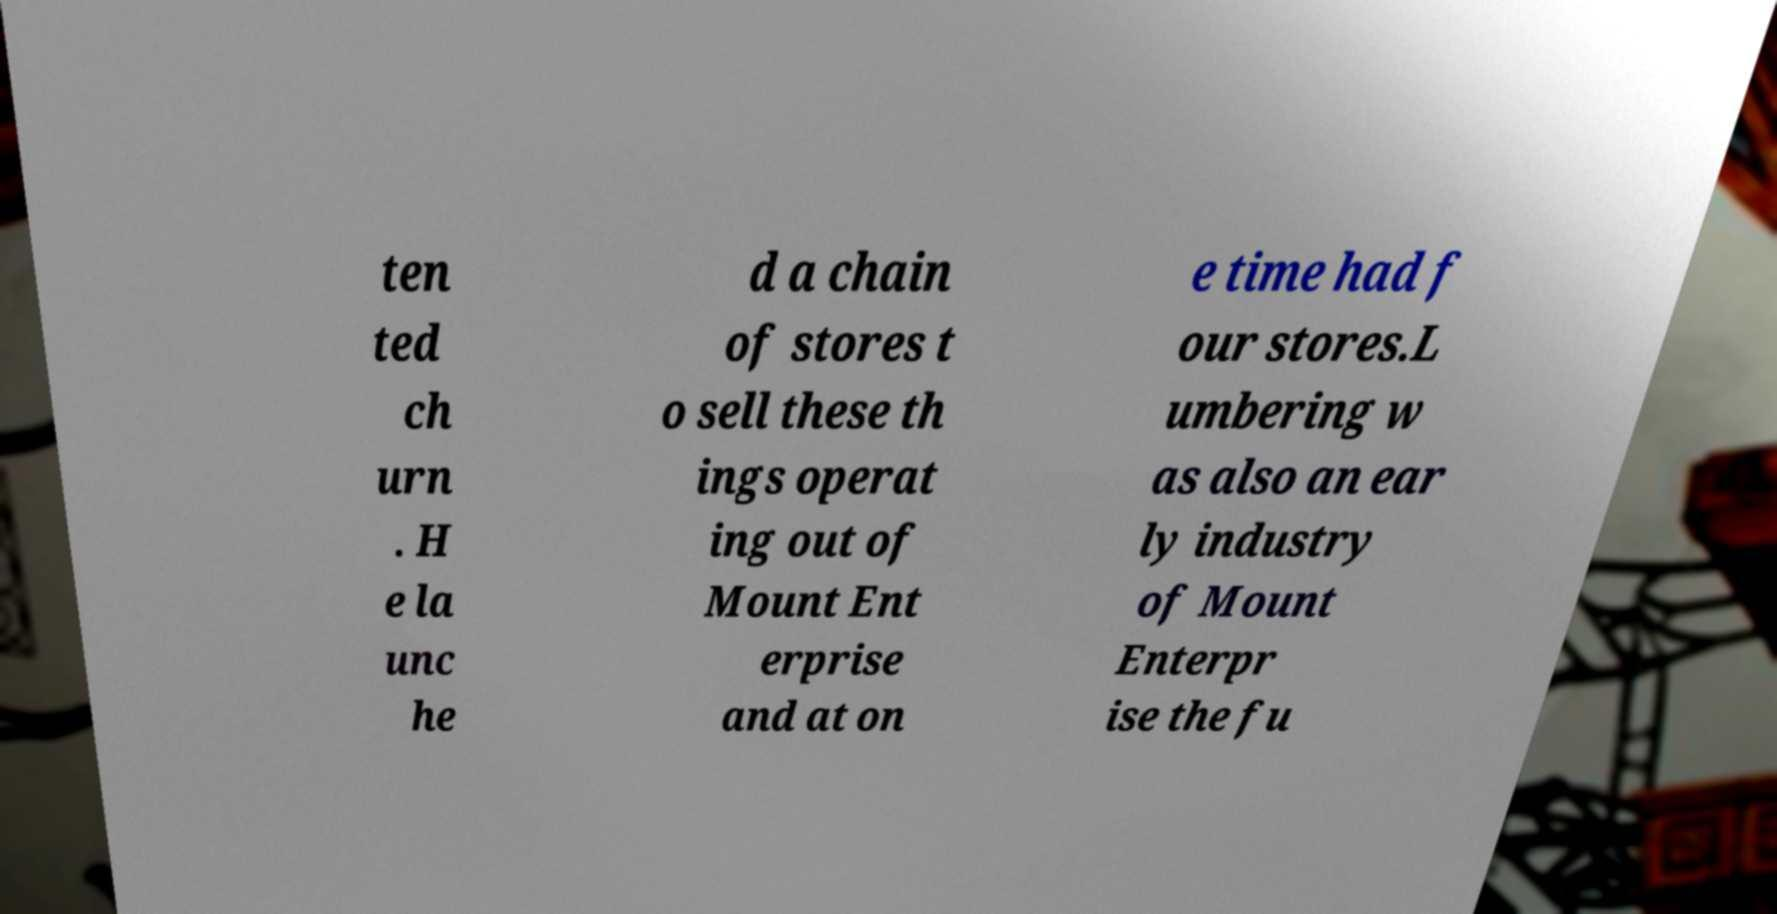Can you read and provide the text displayed in the image?This photo seems to have some interesting text. Can you extract and type it out for me? ten ted ch urn . H e la unc he d a chain of stores t o sell these th ings operat ing out of Mount Ent erprise and at on e time had f our stores.L umbering w as also an ear ly industry of Mount Enterpr ise the fu 